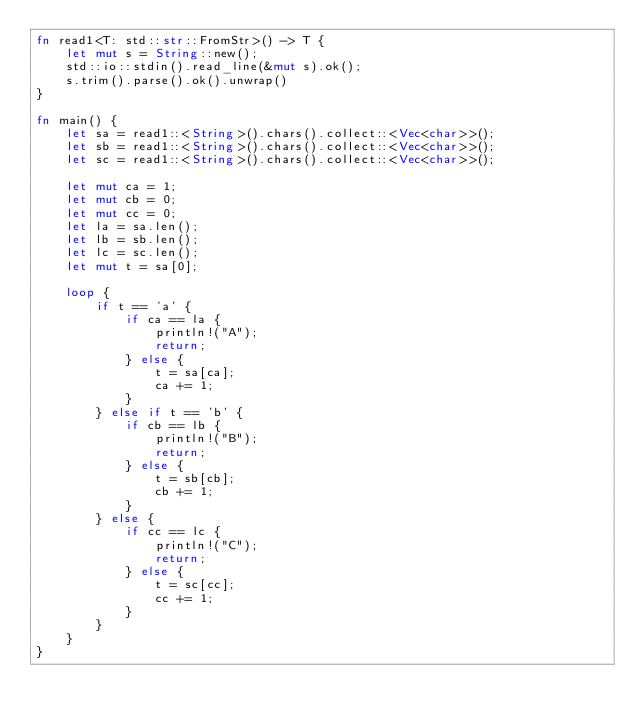Convert code to text. <code><loc_0><loc_0><loc_500><loc_500><_Rust_>fn read1<T: std::str::FromStr>() -> T {
    let mut s = String::new();
    std::io::stdin().read_line(&mut s).ok();
    s.trim().parse().ok().unwrap()
}

fn main() {
    let sa = read1::<String>().chars().collect::<Vec<char>>();
    let sb = read1::<String>().chars().collect::<Vec<char>>();
    let sc = read1::<String>().chars().collect::<Vec<char>>();

    let mut ca = 1;
    let mut cb = 0;
    let mut cc = 0;
    let la = sa.len();
    let lb = sb.len();
    let lc = sc.len();
    let mut t = sa[0];

    loop {
        if t == 'a' {
            if ca == la {
                println!("A");
                return;
            } else {
                t = sa[ca];
                ca += 1;
            }
        } else if t == 'b' {
            if cb == lb {
                println!("B");
                return;
            } else {
                t = sb[cb];
                cb += 1;
            }
        } else {
            if cc == lc {
                println!("C");
                return;
            } else {
                t = sc[cc];
                cc += 1;
            }
        }
    }
}</code> 